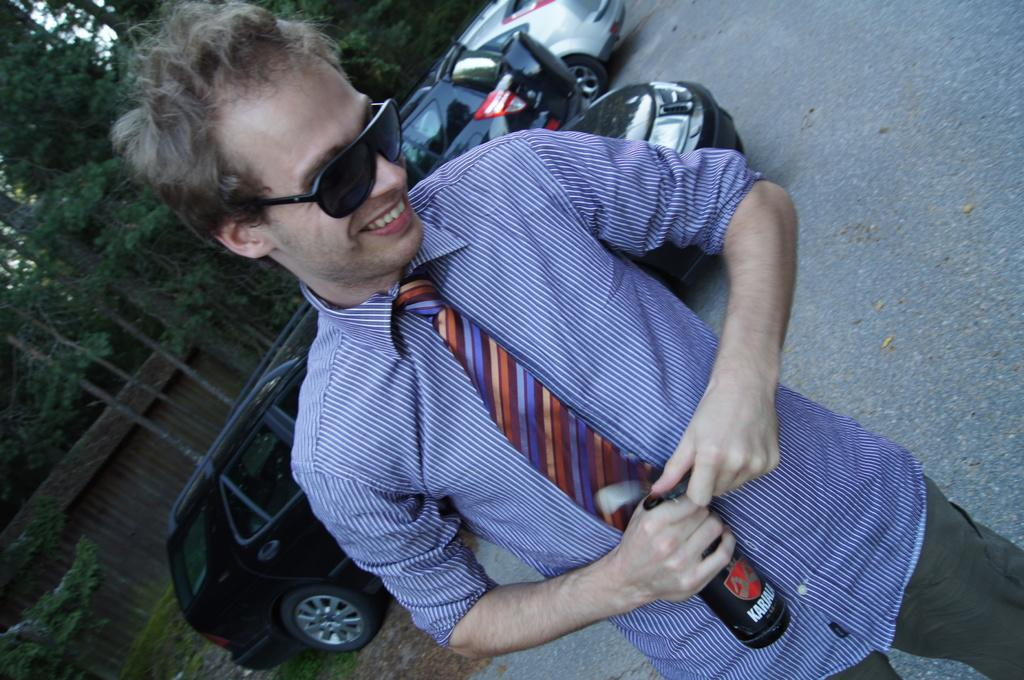Who or what is the main subject in the center of the image? There is a person in the center of the image. What is the person holding in his hand? The person is holding a bottle in his hand. What can be seen in the background of the image? There are trees, a wall, and cars on the road in the background of the image. What type of animal is sitting on the shelf in the image? There is no shelf or animal present in the image. 